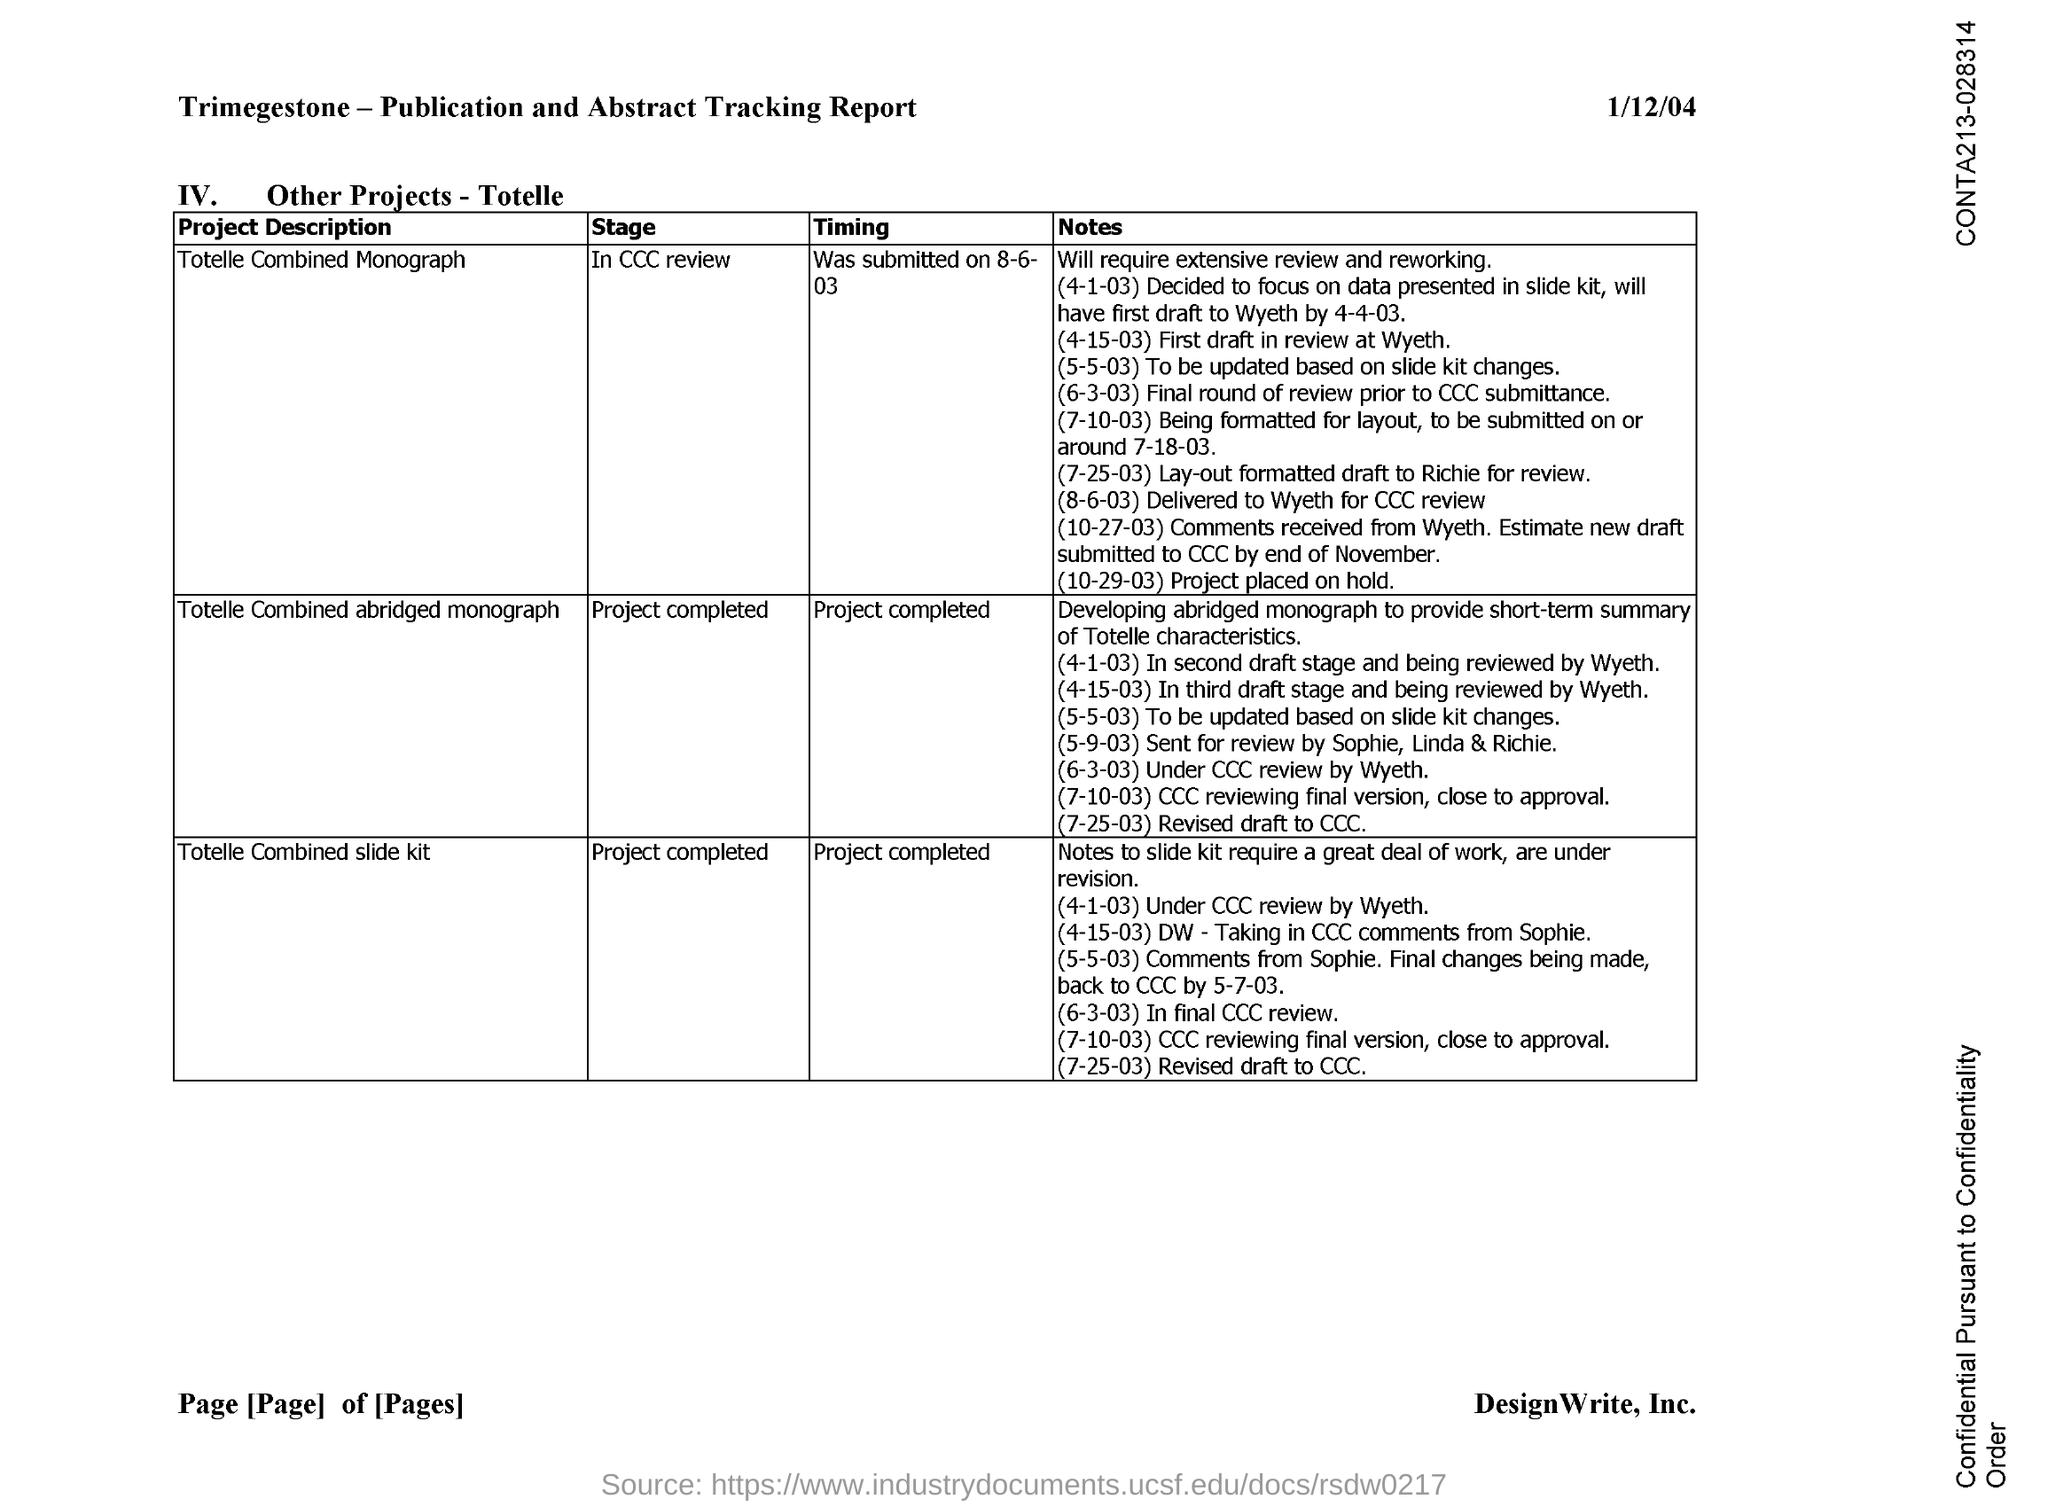What is the date mentioned in the document?
Offer a terse response. 1/12/04. 